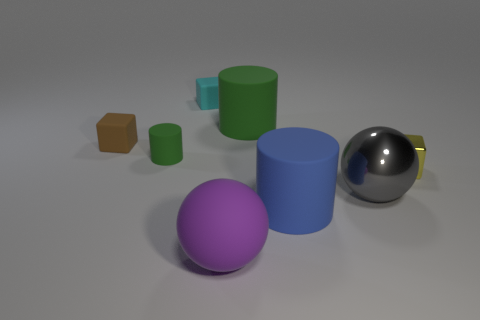There is a small object that is on the right side of the blue rubber object; is its shape the same as the metal object to the left of the tiny yellow cube?
Give a very brief answer. No. The purple object that is the same shape as the gray metal object is what size?
Make the answer very short. Large. How many large purple objects have the same material as the large gray object?
Offer a terse response. 0. What is the blue cylinder made of?
Offer a terse response. Rubber. There is a cyan thing behind the big cylinder in front of the tiny yellow cube; what shape is it?
Give a very brief answer. Cube. There is a green rubber object that is on the left side of the cyan rubber object; what is its shape?
Your response must be concise. Cylinder. How many blocks have the same color as the big rubber ball?
Ensure brevity in your answer.  0. What color is the metallic sphere?
Ensure brevity in your answer.  Gray. There is a matte block behind the small brown rubber block; what number of metallic blocks are behind it?
Make the answer very short. 0. There is a cyan rubber cube; is it the same size as the green object that is left of the cyan matte object?
Ensure brevity in your answer.  Yes. 